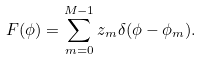Convert formula to latex. <formula><loc_0><loc_0><loc_500><loc_500>F ( \phi ) = \sum _ { m = 0 } ^ { M - 1 } z _ { m } \delta ( \phi - \phi _ { m } ) .</formula> 